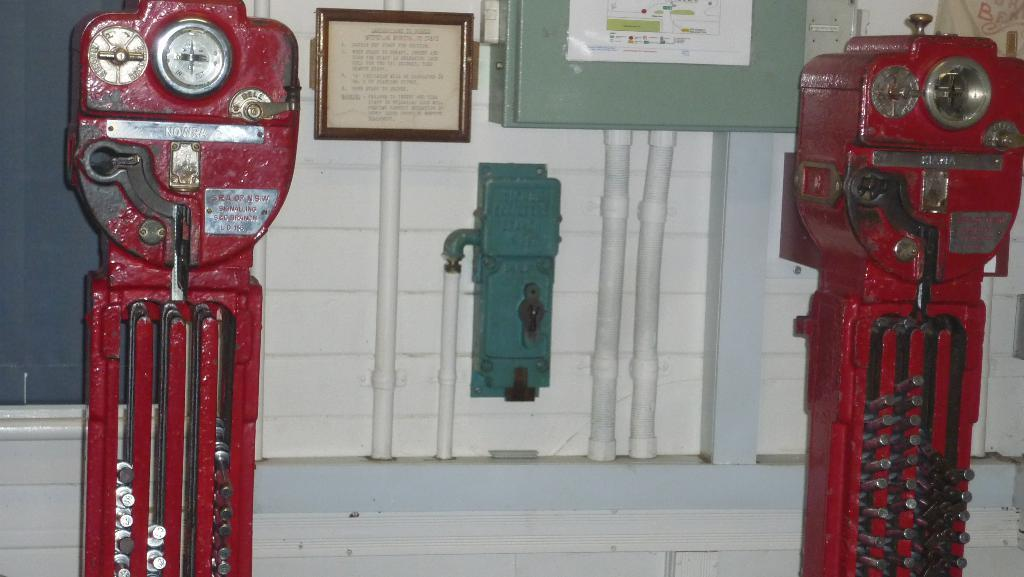What type of objects can be seen in the image? There are mechanical instruments, a photo frame, a box, and a poster with text in the image. Can you describe the poster with text? The poster with text is one of the objects on the wall in the image. What other objects are on the wall in the image? There are other objects on the wall in the image, but their specific details are not mentioned in the provided facts. What type of corn is growing on the mechanical instruments in the image? There is no corn present in the image, as it features mechanical instruments, a photo frame, a box, and a poster with text. 